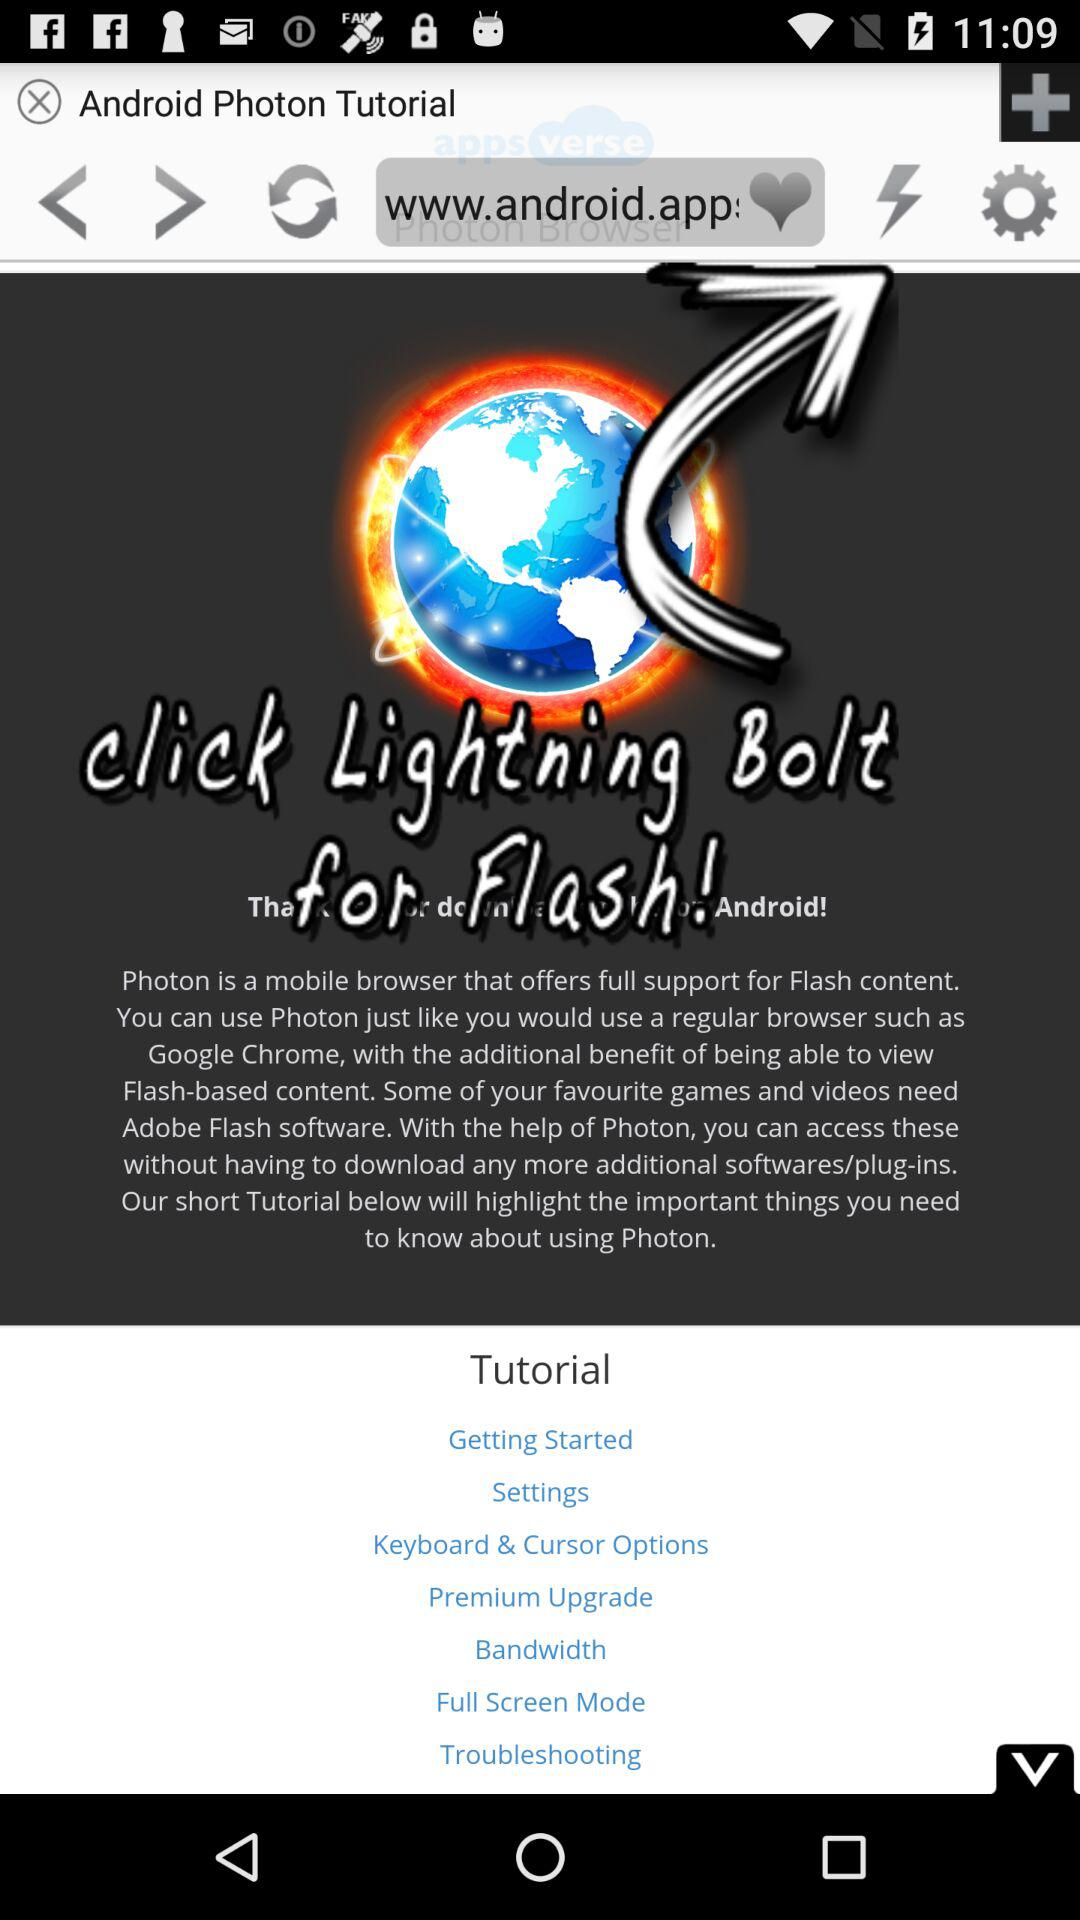What is the app name? The app name is "Photon". 